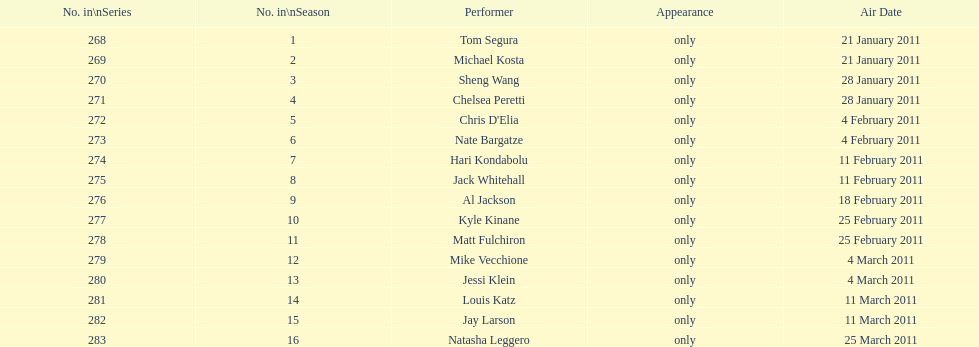What is the total number of unique performers that participated in this season? 16. 